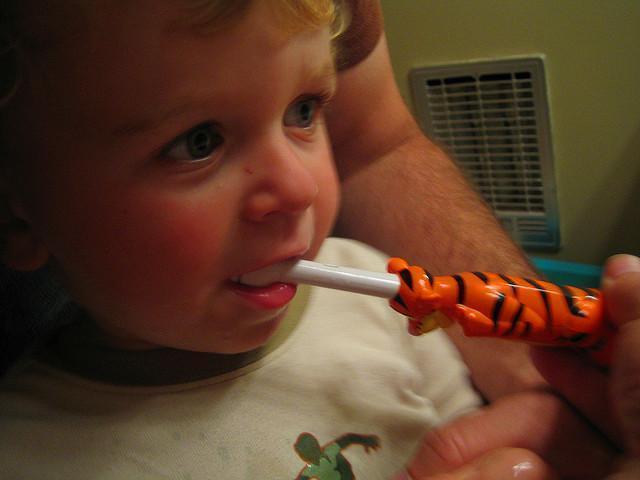What is on the end of tigger's head?
Select the accurate answer and provide justification: `Answer: choice
Rationale: srationale.`
Options: Comb, toothbrush, sucker, hairbrush. Answer: toothbrush.
Rationale: The child is brushing his teeth with it. 